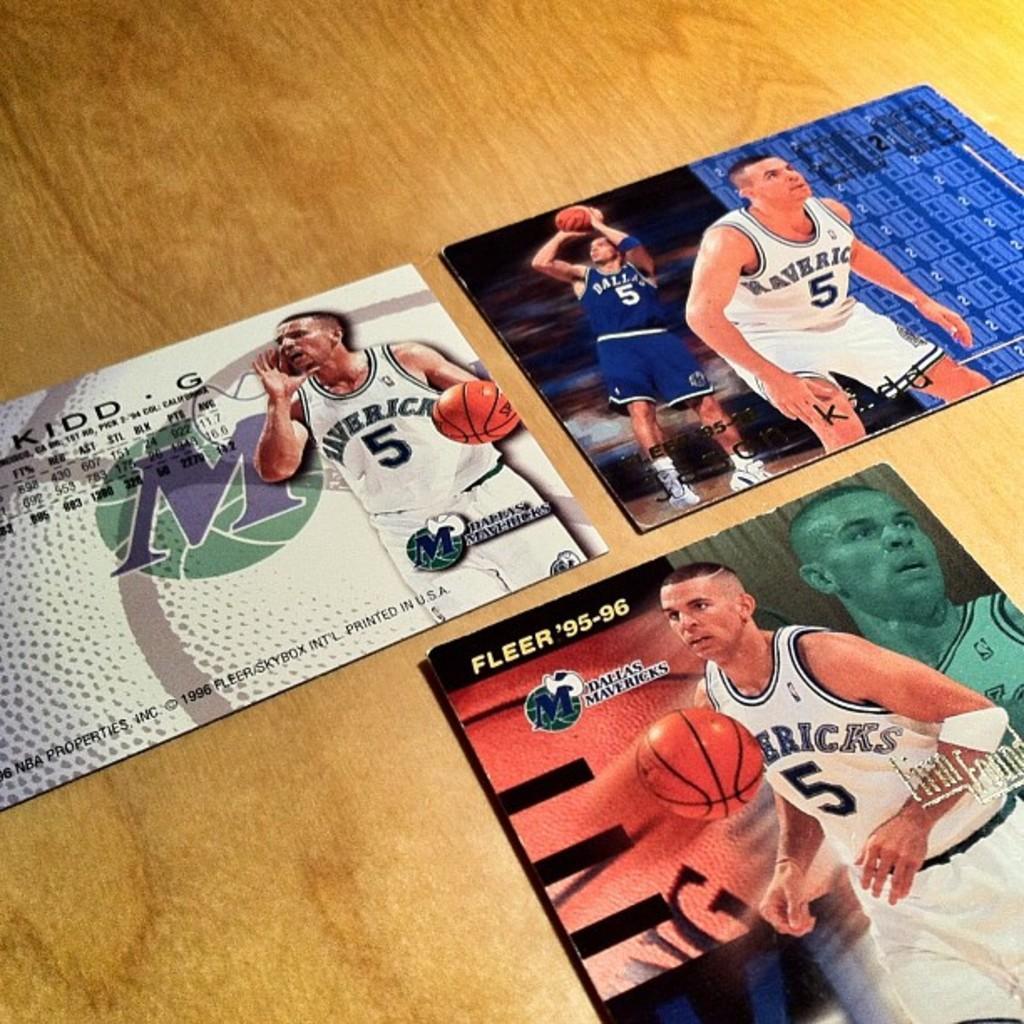In one or two sentences, can you explain what this image depicts? In the picture I can see boards on a wooden surface. On these words I can see photos of men, balls and something written on them. 